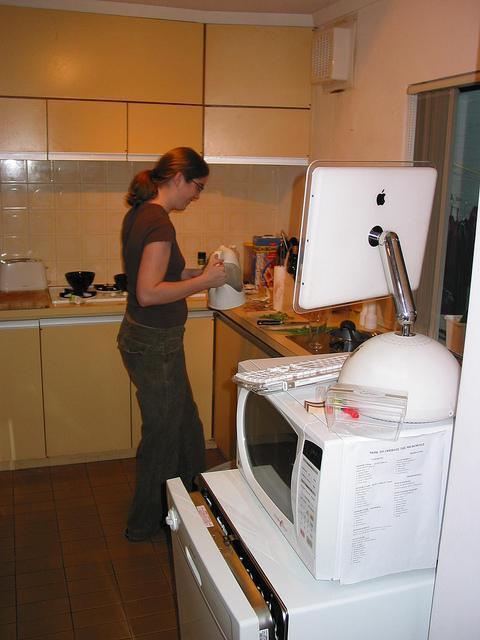How many refrigerators are there?
Give a very brief answer. 1. How many birds are in this scene?
Give a very brief answer. 0. 